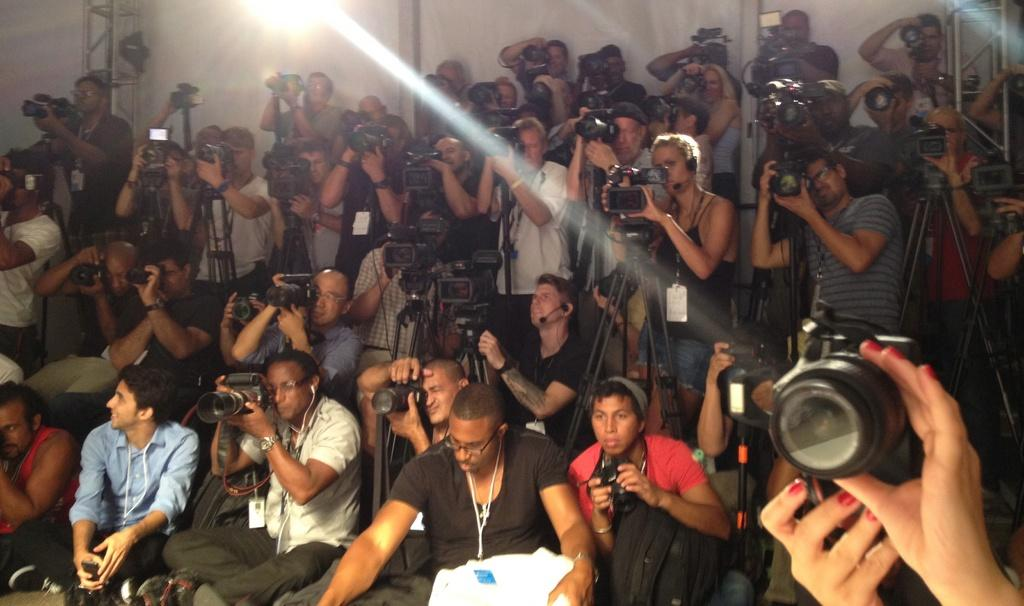What are the people in the image doing? The people in the image are capturing photos and videos. What are the people using to capture photos and videos? The people are using cameras. How are the cameras being held by the people? Each person is holding a camera in their hand. Can you hear the engine running in the image? There is no engine present in the image, as it features people holding cameras. 